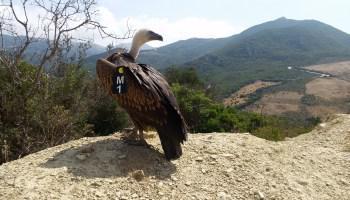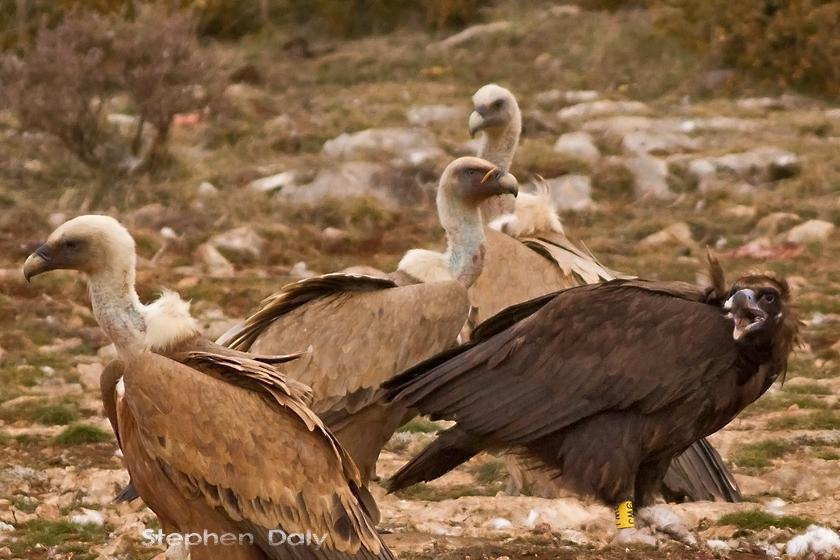The first image is the image on the left, the second image is the image on the right. Examine the images to the left and right. Is the description "a vulture has a tag on its left wing" accurate? Answer yes or no. Yes. The first image is the image on the left, the second image is the image on the right. Given the left and right images, does the statement "There are more than four birds in the image to the right." hold true? Answer yes or no. No. 